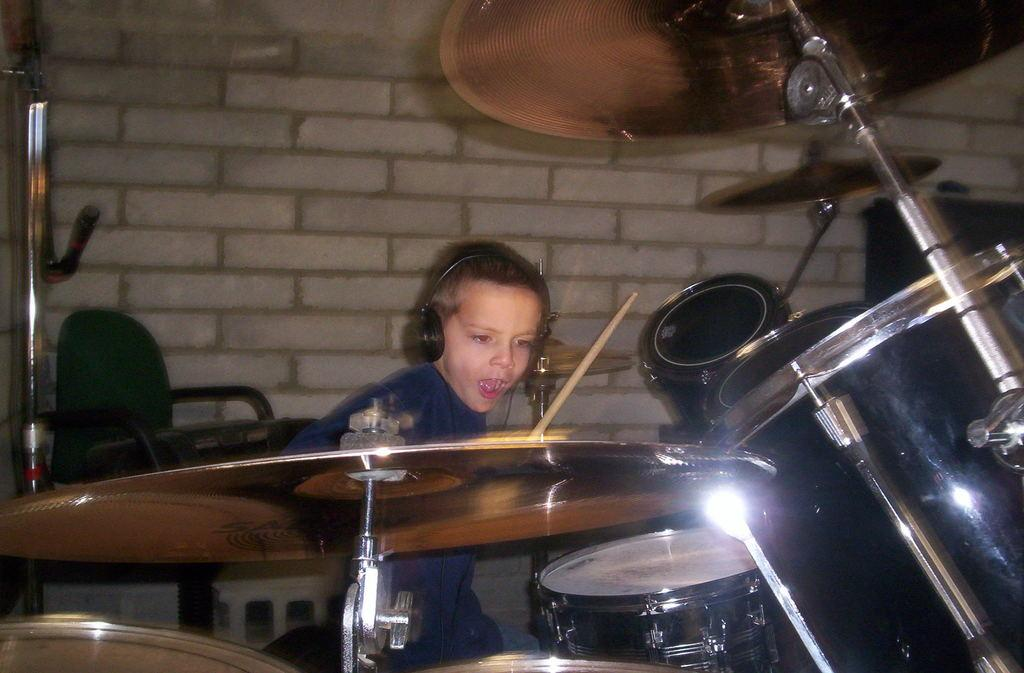Who is the main subject in the image? There is a child in the image. What is the child interacting with in the image? The child is interacting with musical instruments in front of them. What can be seen in the background of the image? There is a chair and a wall in the background of the image. What type of writer is sitting on the chair in the background of the image? There is no writer present in the image; it only shows a child with musical instruments and a chair and wall in the background. 